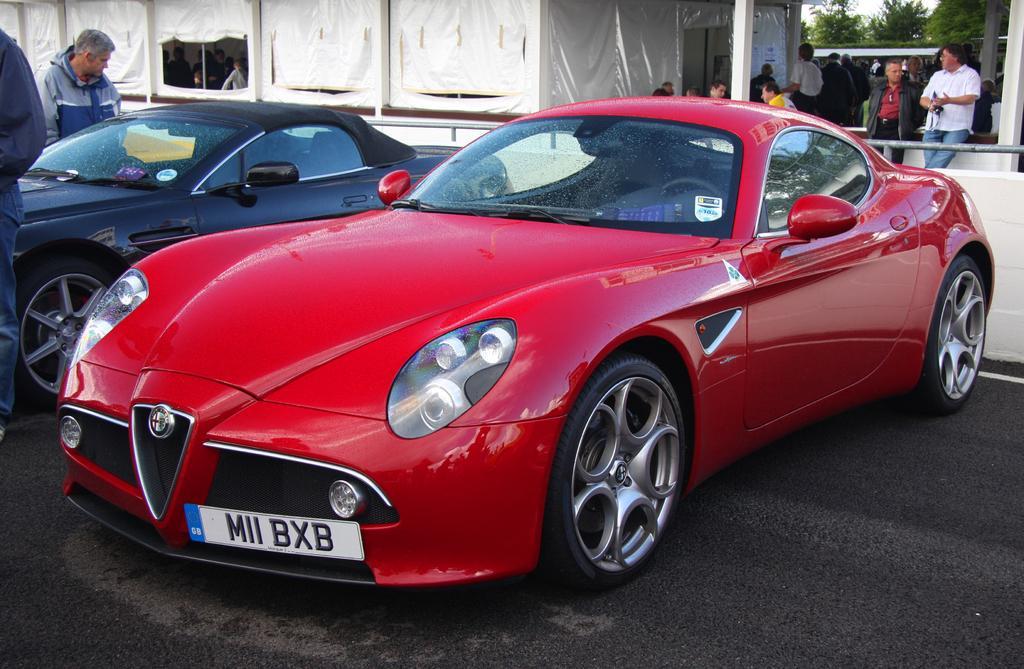Can you describe this image briefly? In this image there are two cars which are parked one beside the other. In the background there is a tent. On the right side top there are few people standing on the floor, while some people are sitting in the chairs. On the left side there is a man standing on the floor. 